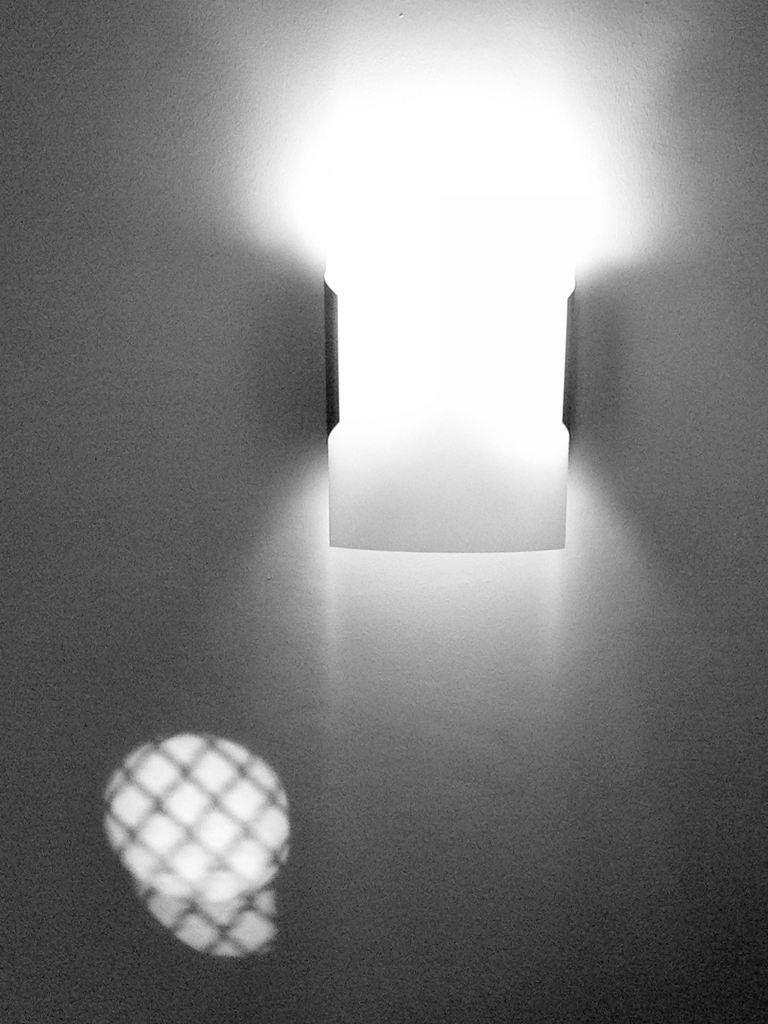What can be seen in the image that provides illumination? There is light in the image. What type of structure is visible in the image? There is a wall in the image. Can you hear a woman crying in the image? There is no woman or crying sound present in the image. What type of food is being prepared in the image? There is no food preparation or rice visible in the image. 